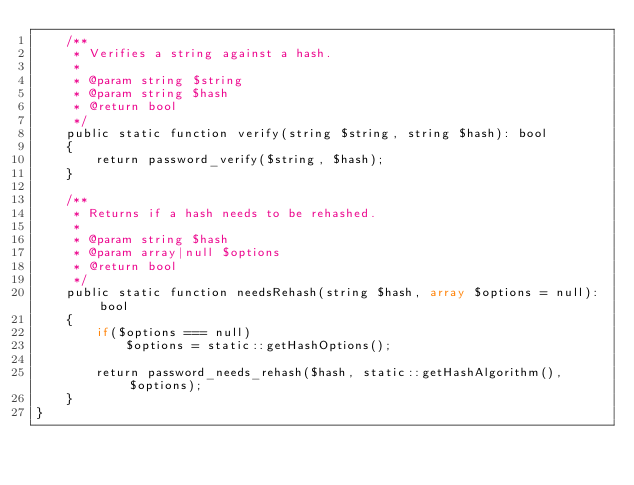<code> <loc_0><loc_0><loc_500><loc_500><_PHP_>    /**
     * Verifies a string against a hash.
     *
     * @param string $string
     * @param string $hash
     * @return bool
     */
    public static function verify(string $string, string $hash): bool
    {
        return password_verify($string, $hash);
    }

    /**
     * Returns if a hash needs to be rehashed.
     *
     * @param string $hash
     * @param array|null $options
     * @return bool
     */
    public static function needsRehash(string $hash, array $options = null): bool
    {
        if($options === null)
            $options = static::getHashOptions();

        return password_needs_rehash($hash, static::getHashAlgorithm(), $options);
    }
}</code> 